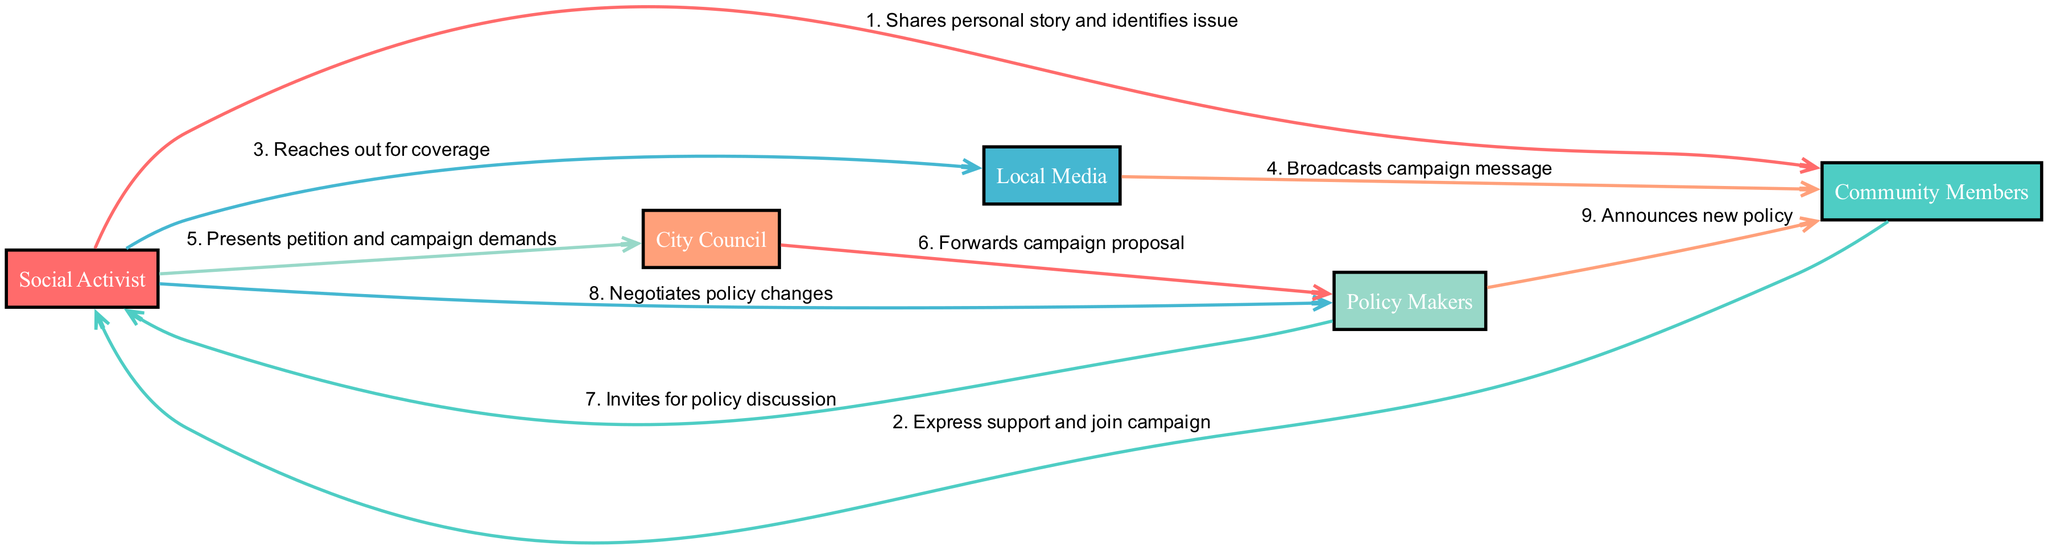What is the first action taken in the campaign? The first action in the sequence is where the Social Activist shares their personal story and identifies the issue. This is the starting point of the grassroots campaign that initiates the engagement of Community Members.
Answer: Shares personal story and identifies issue How many actors are involved in the journey of the campaign? By counting the unique entities listed in the 'actors' section of the diagram, we see there are five actors: Social Activist, Community Members, Local Media, City Council, and Policy Makers.
Answer: 5 What action follows after the Local Media broadcasts the campaign message? After Local Media broadcasts the campaign message, the next action is where the Social Activist presents the petition and campaign demands to the City Council. This illustrates the progression from raising awareness to formalizing the demands.
Answer: Presents petition and campaign demands Which actor invites the Social Activist for a policy discussion? The Policy Makers are the ones who invite the Social Activist for a policy discussion, as shown in the diagram connecting Policy Makers to Social Activist after the City Council forwards the campaign proposal.
Answer: Policy Makers What is the final outcome that the Policy Makers announce? The final outcome indicated in the campaign sequence is that the Policy Makers announce a new policy to the Community Members, which shows the successful conclusion of the grassroots campaign effort.
Answer: Announces new policy What is the relationship between the Social Activist and Community Members? The relationship is reciprocal, where the Social Activist shares a personal story to identify the issue, and the Community Members respond by expressing support and joining the campaign. This illustrates an initial bond and collaboration in the campaign.
Answer: Shares personal story and identifies issue; Express support and join campaign 